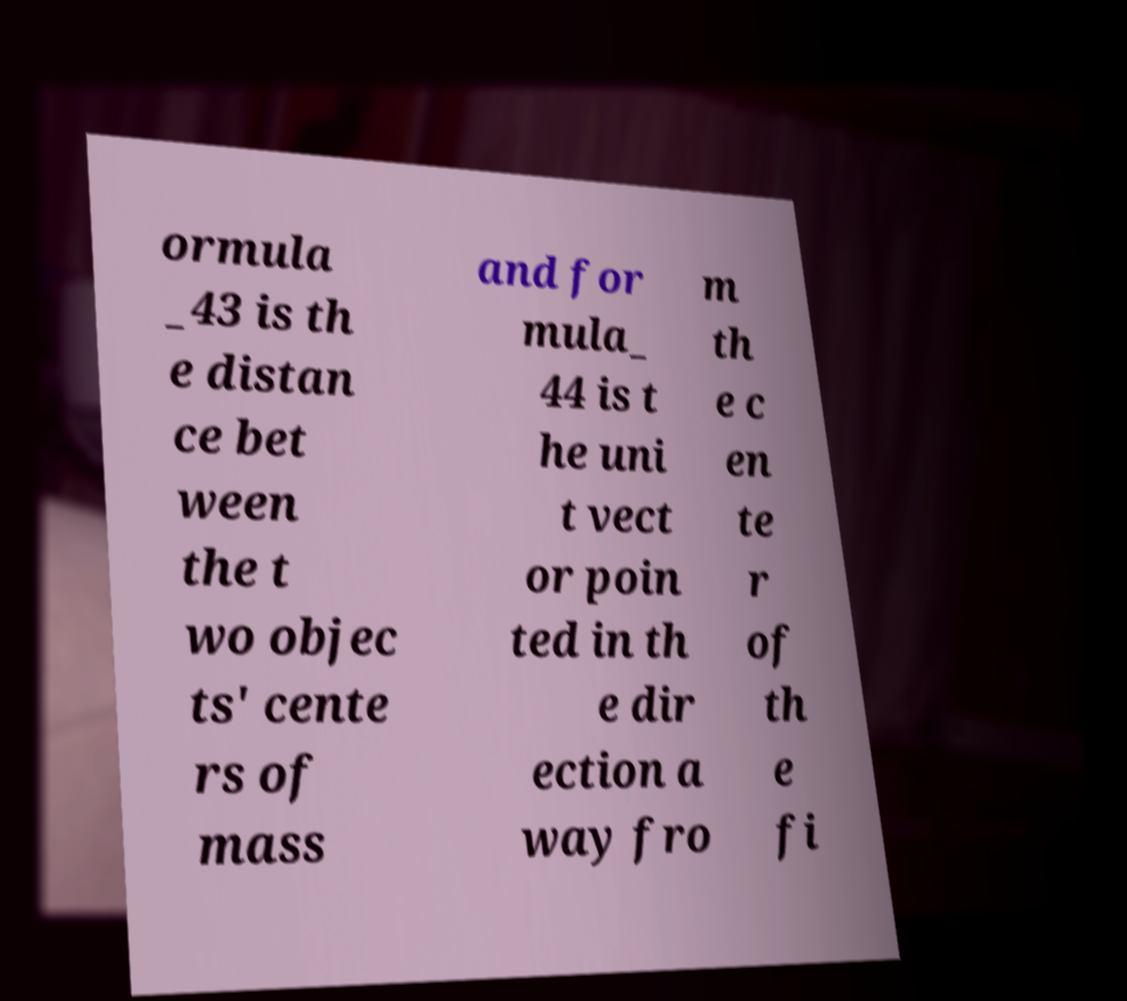Could you assist in decoding the text presented in this image and type it out clearly? ormula _43 is th e distan ce bet ween the t wo objec ts' cente rs of mass and for mula_ 44 is t he uni t vect or poin ted in th e dir ection a way fro m th e c en te r of th e fi 